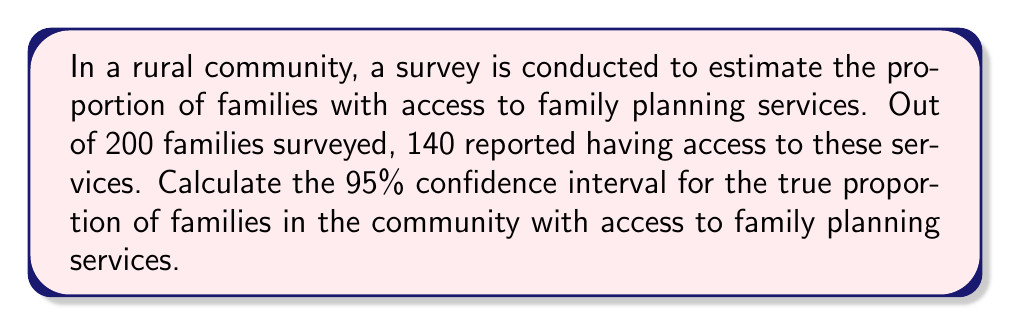Solve this math problem. Let's approach this step-by-step:

1) First, we need to calculate the sample proportion:
   $\hat{p} = \frac{\text{number of successes}}{\text{sample size}} = \frac{140}{200} = 0.7$

2) The formula for the confidence interval is:
   $$\hat{p} \pm z_{\alpha/2} \sqrt{\frac{\hat{p}(1-\hat{p})}{n}}$$

   Where:
   - $\hat{p}$ is the sample proportion
   - $z_{\alpha/2}$ is the critical value (for 95% confidence, this is 1.96)
   - $n$ is the sample size

3) Let's substitute our values:
   $$0.7 \pm 1.96 \sqrt{\frac{0.7(1-0.7)}{200}}$$

4) Simplify inside the square root:
   $$0.7 \pm 1.96 \sqrt{\frac{0.7(0.3)}{200}} = 0.7 \pm 1.96 \sqrt{\frac{0.21}{200}}$$

5) Calculate:
   $$0.7 \pm 1.96 \sqrt{0.00105} = 0.7 \pm 1.96(0.0324) = 0.7 \pm 0.0635$$

6) Therefore, the confidence interval is:
   $$(0.7 - 0.0635, 0.7 + 0.0635) = (0.6365, 0.7635)$$

We can be 95% confident that the true proportion of families in the community with access to family planning services is between 0.6365 and 0.7635, or between 63.65% and 76.35%.
Answer: (0.6365, 0.7635) 